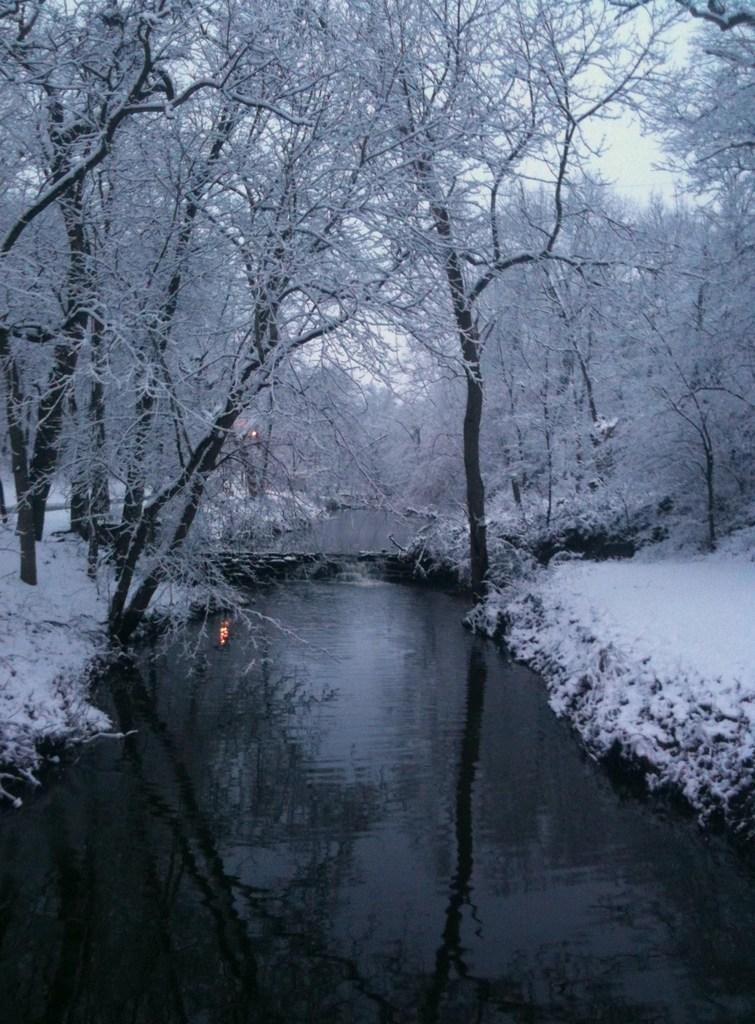What is covering is on the trees and plants in the image? There is snow on the trees and plants in the image. What can be seen besides the snow-covered trees and plants? There is water visible in the image. What is visible in the background of the image? The sky is visible in the background of the image. What type of heat source is present in the image? There is no heat source present in the image; it features snow-covered trees and plants. What type of trade is being conducted in the image? There is no trade being conducted in the image; it features snow-covered trees and plants. 